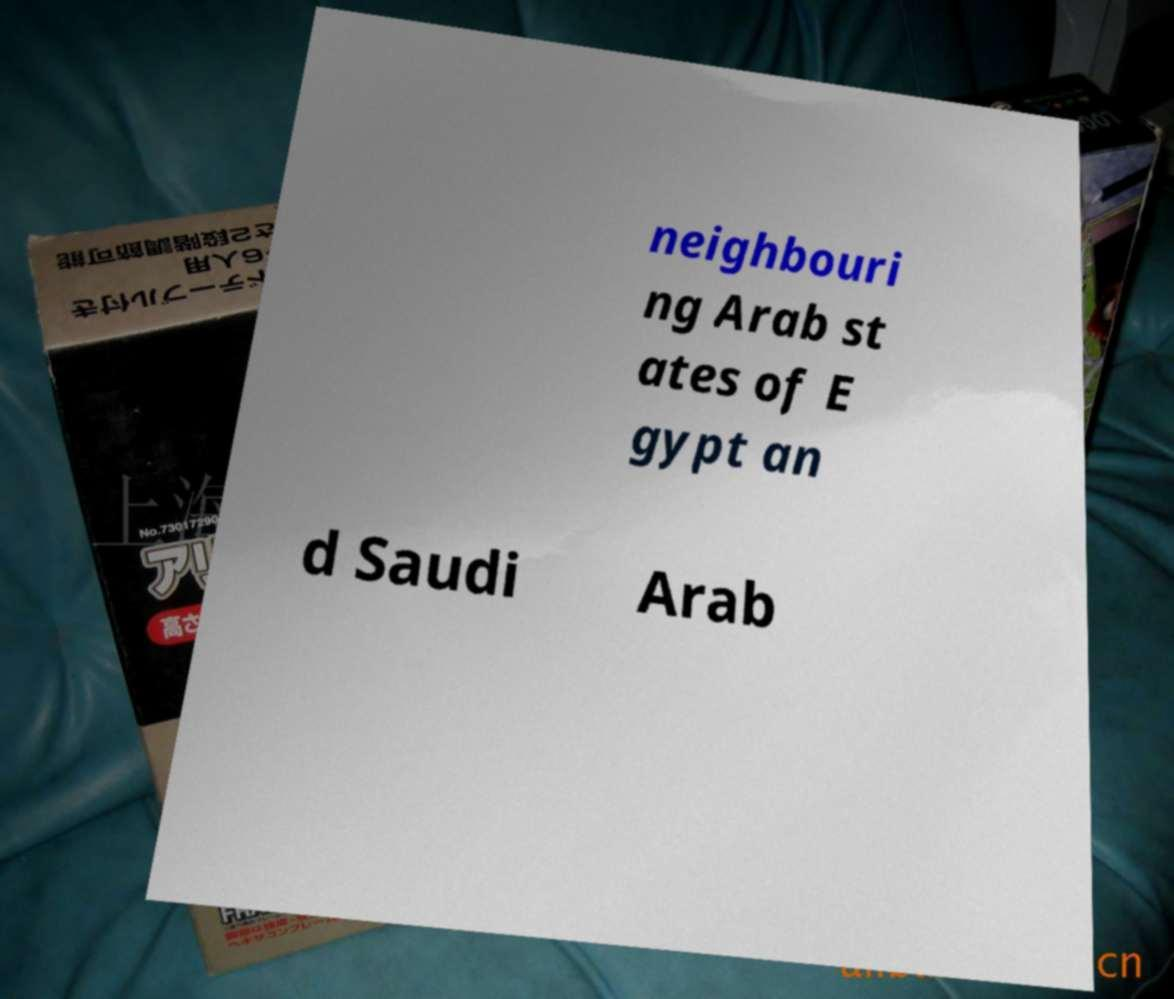Please read and relay the text visible in this image. What does it say? neighbouri ng Arab st ates of E gypt an d Saudi Arab 